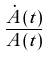Convert formula to latex. <formula><loc_0><loc_0><loc_500><loc_500>\frac { \dot { A } ( t ) } { A ( t ) }</formula> 